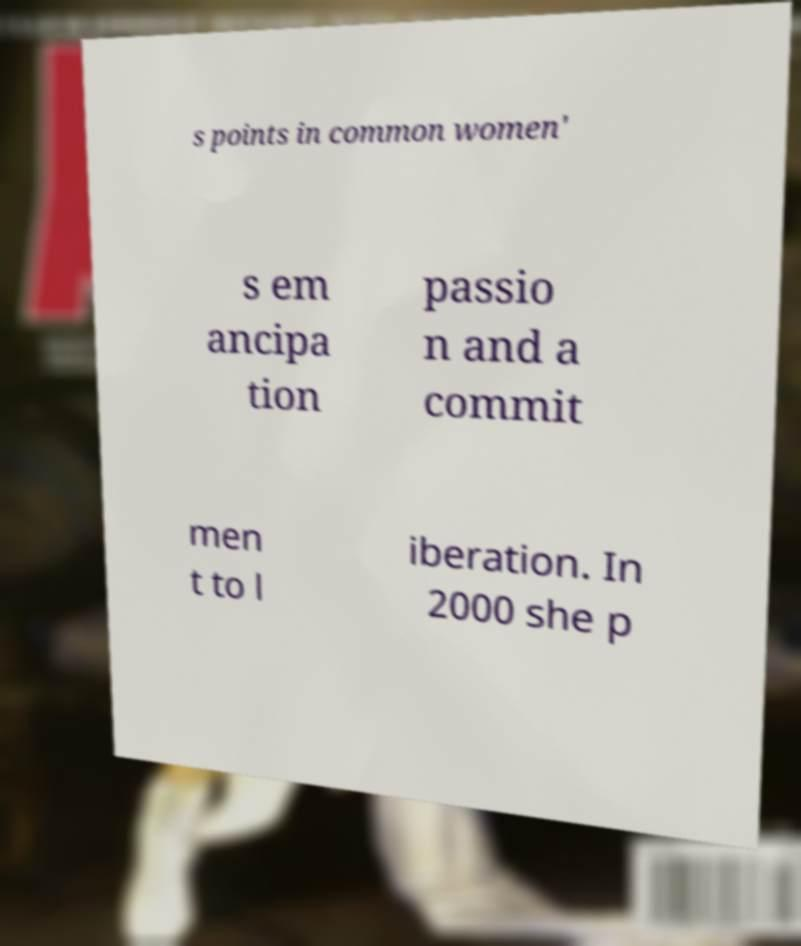I need the written content from this picture converted into text. Can you do that? s points in common women' s em ancipa tion passio n and a commit men t to l iberation. In 2000 she p 